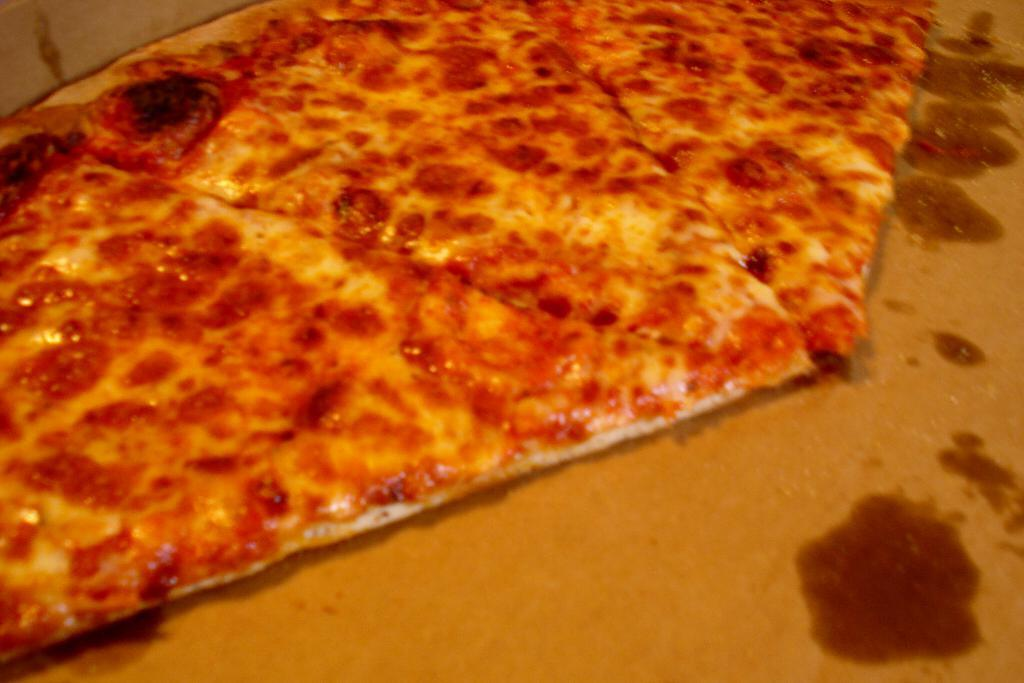What is the color of the surface in the image? The surface in the image is brown. What is on top of the brown surface? There are pizza pieces on the surface. What colors can be seen on the pizza pieces? The pizza pieces have cream, orange, black, and red colors. Are there any bears playing a game of test club in the image? There are no bears or any game of test club present in the image. 